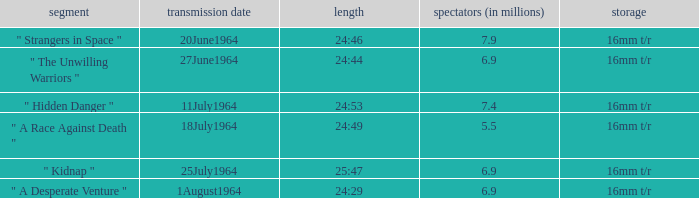Parse the full table. {'header': ['segment', 'transmission date', 'length', 'spectators (in millions)', 'storage'], 'rows': [['" Strangers in Space "', '20June1964', '24:46', '7.9', '16mm t/r'], ['" The Unwilling Warriors "', '27June1964', '24:44', '6.9', '16mm t/r'], ['" Hidden Danger "', '11July1964', '24:53', '7.4', '16mm t/r'], ['" A Race Against Death "', '18July1964', '24:49', '5.5', '16mm t/r'], ['" Kidnap "', '25July1964', '25:47', '6.9', '16mm t/r'], ['" A Desperate Venture "', '1August1964', '24:29', '6.9', '16mm t/r']]} What is run time when there were 7.4 million viewers? 24:53. 